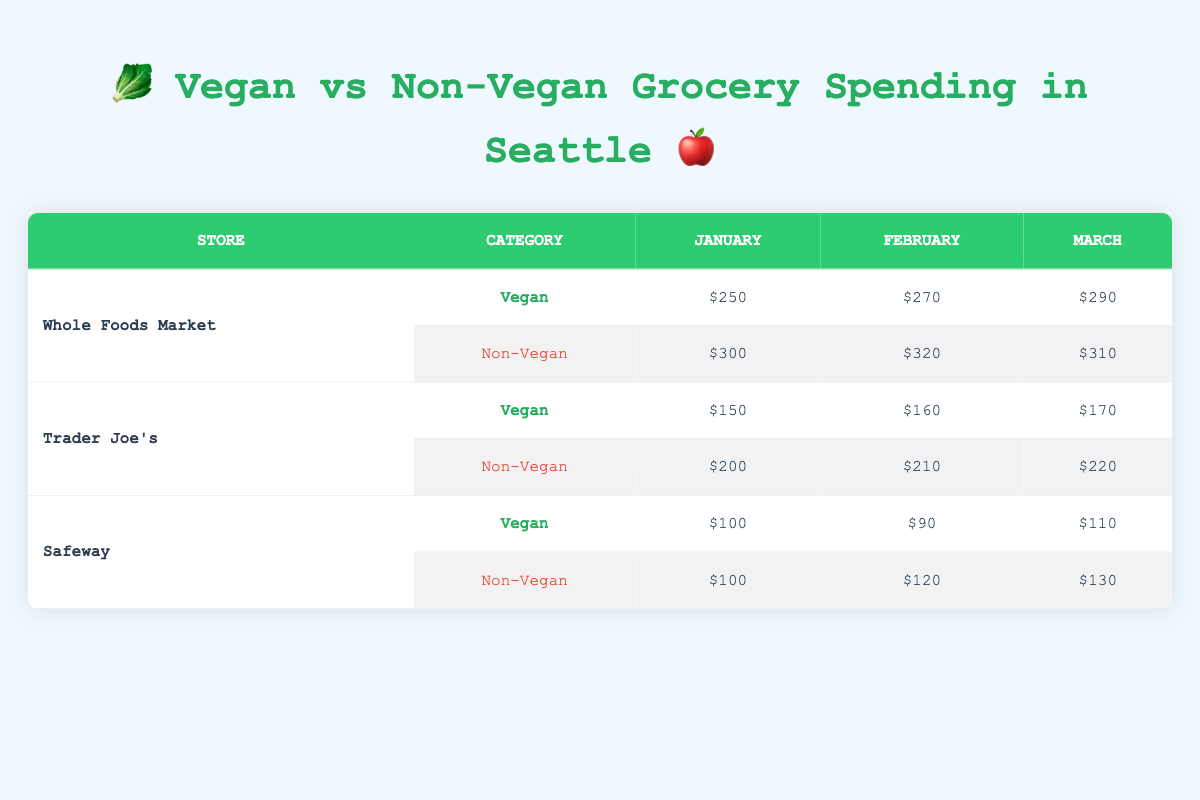What was the total spending on vegan products at Whole Foods Market in January? In January, the vegan spending at Whole Foods Market was $250. Since we are looking for just one data point, we don't need to combine any values.
Answer: 250 What is the total amount spent on non-vegan products across all stores in February? For non-vegan products in February, Whole Foods Market spent $320, Trader Joe's spent $210, and Safeway spent $120. Adding these amounts together gives us $320 + $210 + $120 = $650.
Answer: 650 Did Trader Joe's spend more on vegan or non-vegan products in March? In March, Trader Joe's spent $170 on vegan products and $220 on non-vegan products. Since $220 is greater than $170, Trader Joe's spent more on non-vegan products.
Answer: Yes Which store had the highest spending on vegan products in February? In February, Whole Foods Market spent $270, Trader Joe's spent $160, and Safeway spent $90 on vegan products. Comparing these values, the highest spending is at Whole Foods Market with $270.
Answer: Whole Foods Market What is the difference in spending on non-vegan products between Trader Joe's and Safeway in January? In January, Trader Joe's spent $200 on non-vegan products and Safeway spent $100. The difference is calculated as $200 - $100 = $100.
Answer: 100 What was the average spending on vegan products across all stores for the month of January? In January, the vegan spending was $250 at Whole Foods Market, $150 at Trader Joe's, and $100 at Safeway. The total spending is $250 + $150 + $100 = $500. There are three stores, so the average is $500 / 3 = $166.67.
Answer: 166.67 Which month and store had the lowest total spending on vegan products? The lowest total spending on vegan products can be found by examining each month and store. For January,  Whole Foods Market spent $250, Trader Joe's $150, and Safeway $100. February saw $270 (Whole Foods), $160 (Trader Joe's), and $90 (Safeway). March had Whole Foods at $290, Trader Joe's at $170, and Safeway at $110. The lowest amount is $90 at Safeway in February.
Answer: Safeway in February What is the total spending on vegan products for Safeway across all months? For Safeway, the vegan spending is $100 in January, $90 in February, and $110 in March. Adding these amounts gives $100 + $90 + $110 = $300.
Answer: 300 